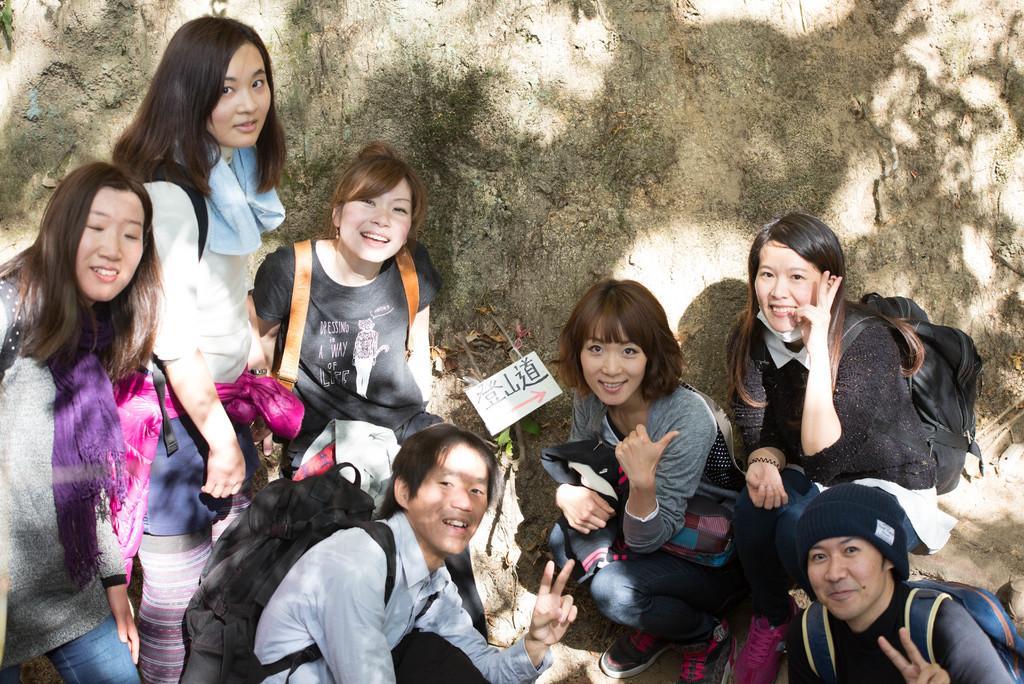Please provide a concise description of this image. In this image there are group of girls who are posing for the picture. Behind them there is a big rock. All the girls are wearing the bags. There is a sticker on the wall. 